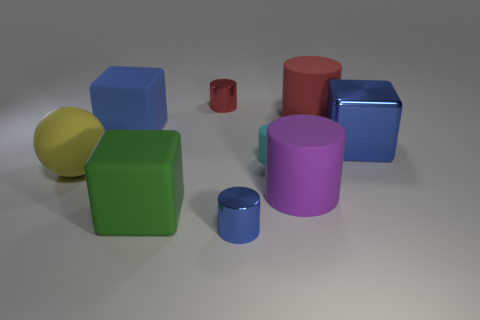There is a tiny metal thing that is the same color as the metallic block; what shape is it?
Your answer should be compact. Cylinder. There is a tiny thing that is in front of the big sphere; is it the same color as the large shiny object?
Keep it short and to the point. Yes. There is a big yellow thing that is made of the same material as the green thing; what shape is it?
Ensure brevity in your answer.  Sphere. Is there anything else of the same color as the small matte cylinder?
Make the answer very short. No. There is a large red thing that is the same shape as the small cyan object; what material is it?
Offer a very short reply. Rubber. What number of other things are there of the same size as the cyan rubber thing?
Your answer should be very brief. 2. What is the small red cylinder made of?
Give a very brief answer. Metal. Are there more small rubber cylinders in front of the red rubber cylinder than gray metal cylinders?
Offer a very short reply. Yes. Are any yellow rubber objects visible?
Give a very brief answer. Yes. How many other objects are there of the same shape as the red rubber thing?
Your answer should be compact. 4. 